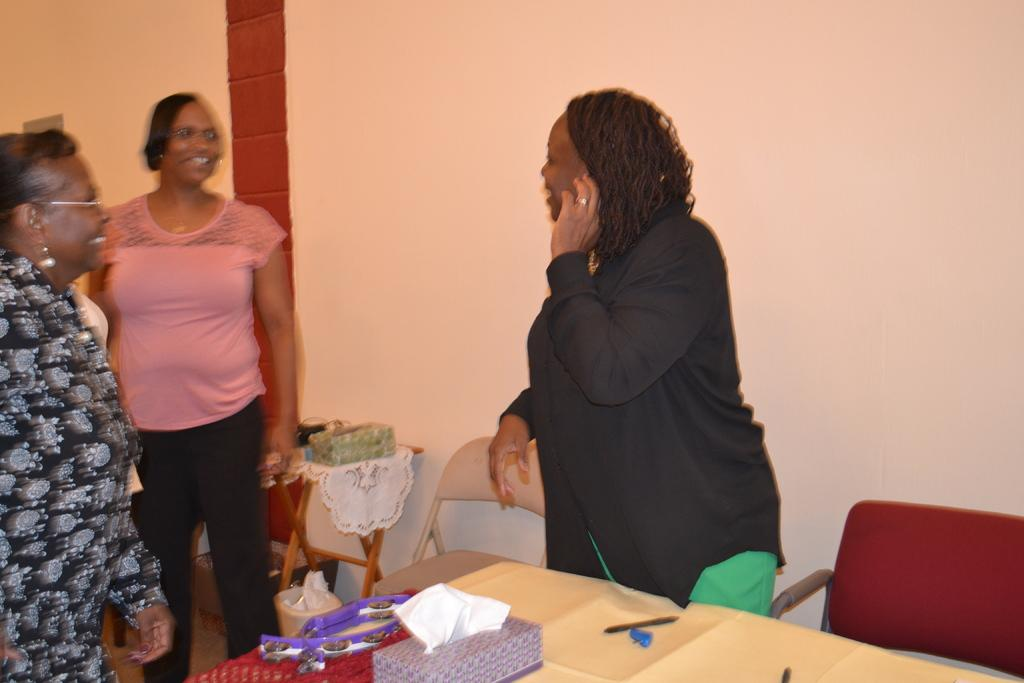How many women are in the image? There are three women in the image. What are the women doing in the image? The women are standing in the image. What expressions do the women have on their faces? The women have smiles on their faces. What can be seen in the background of the image? There are chairs and a table in the background of the image. Can you tell me which woman is wearing a crown in the image? There is no crown present in the image; the women are not wearing any headwear. What type of station is visible in the image? There is no station present in the image; it features three women standing with smiles on their faces and a background with chairs and a table. 